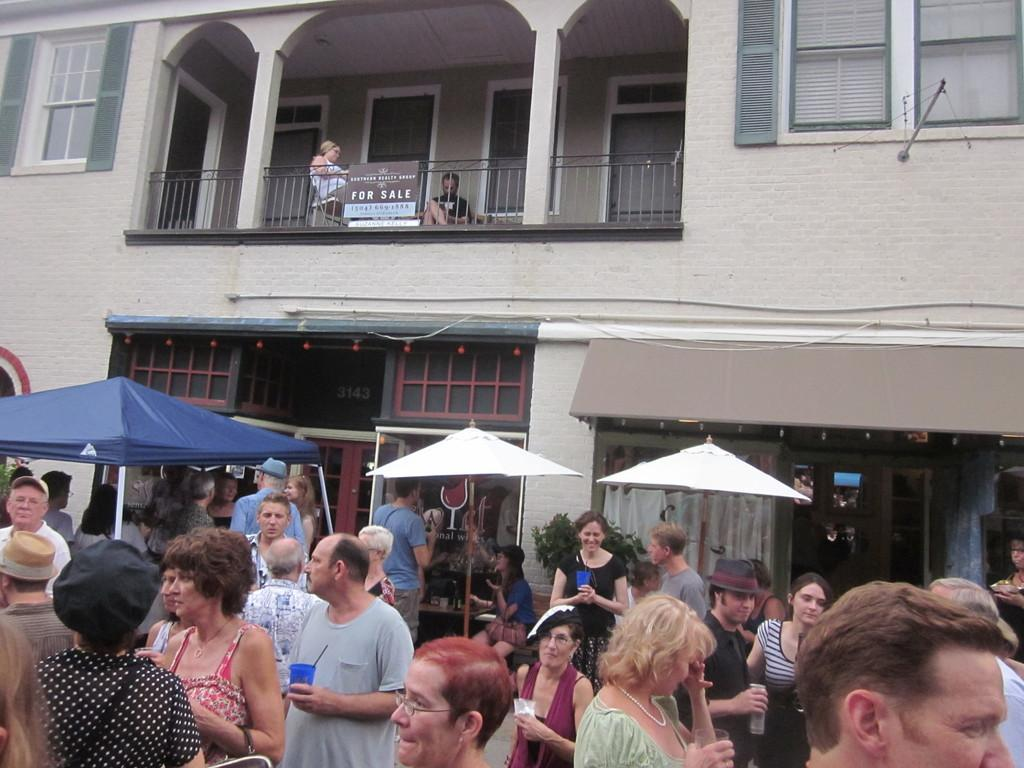<image>
Relay a brief, clear account of the picture shown. A for sale sign hangs above a busy crowded street. 